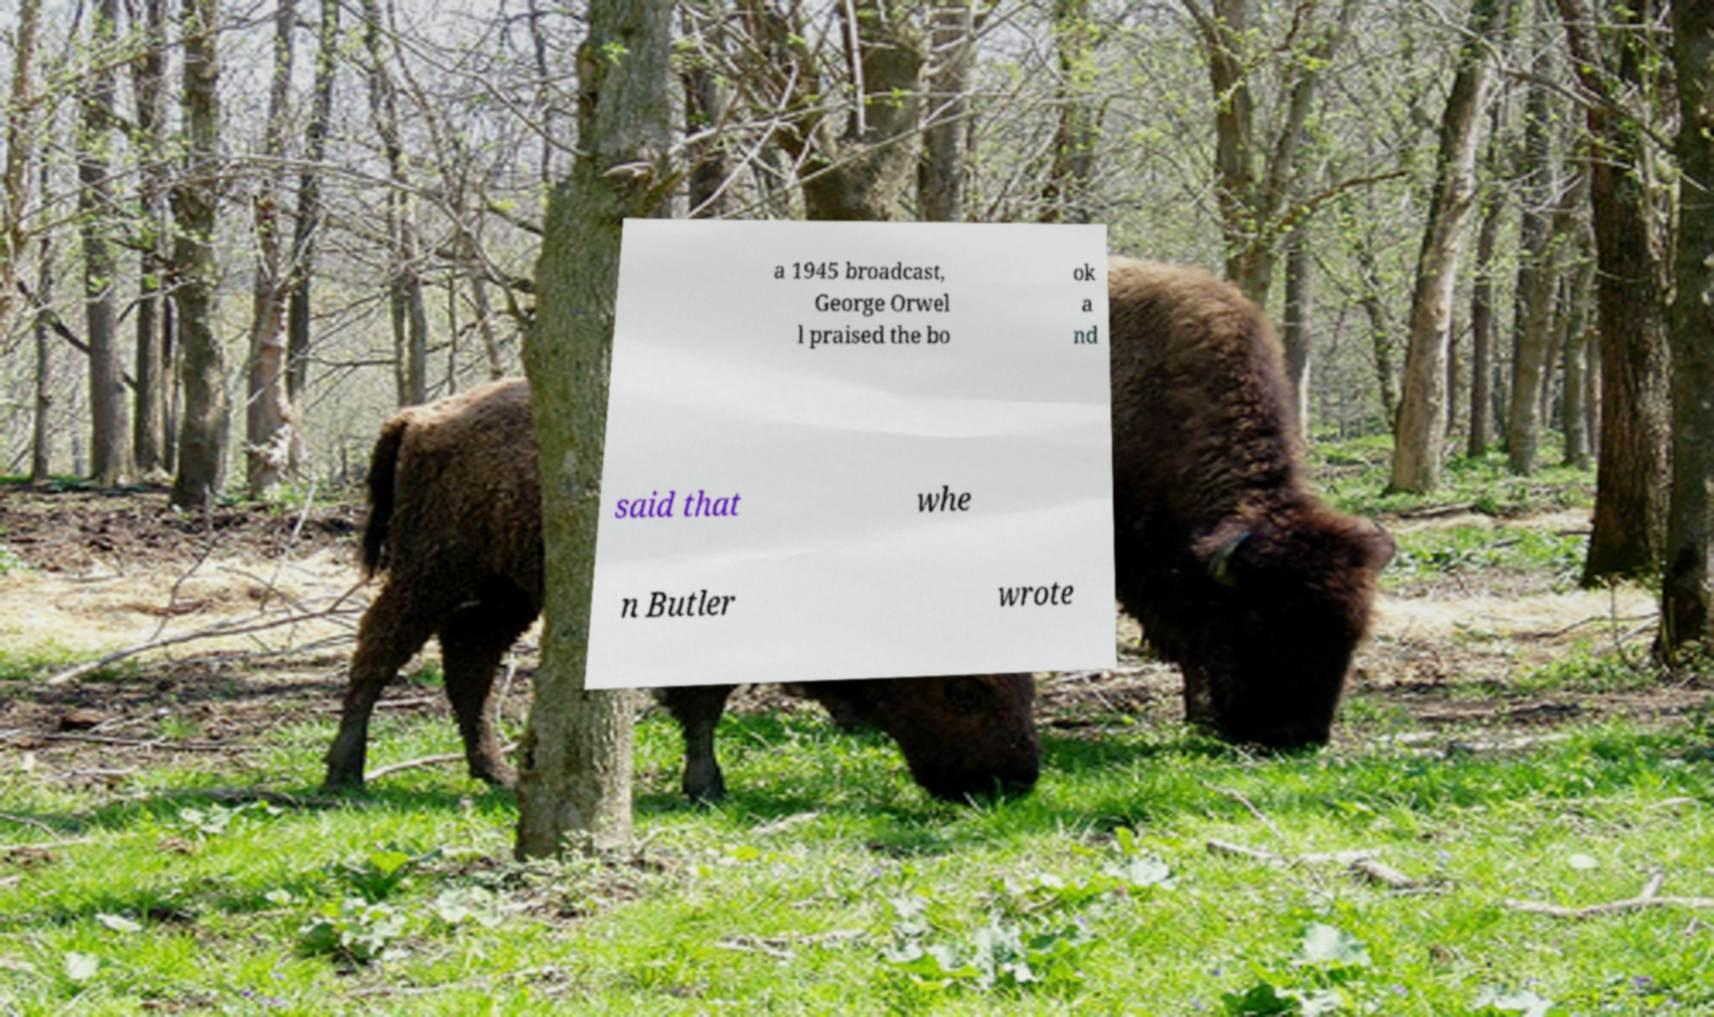For documentation purposes, I need the text within this image transcribed. Could you provide that? a 1945 broadcast, George Orwel l praised the bo ok a nd said that whe n Butler wrote 